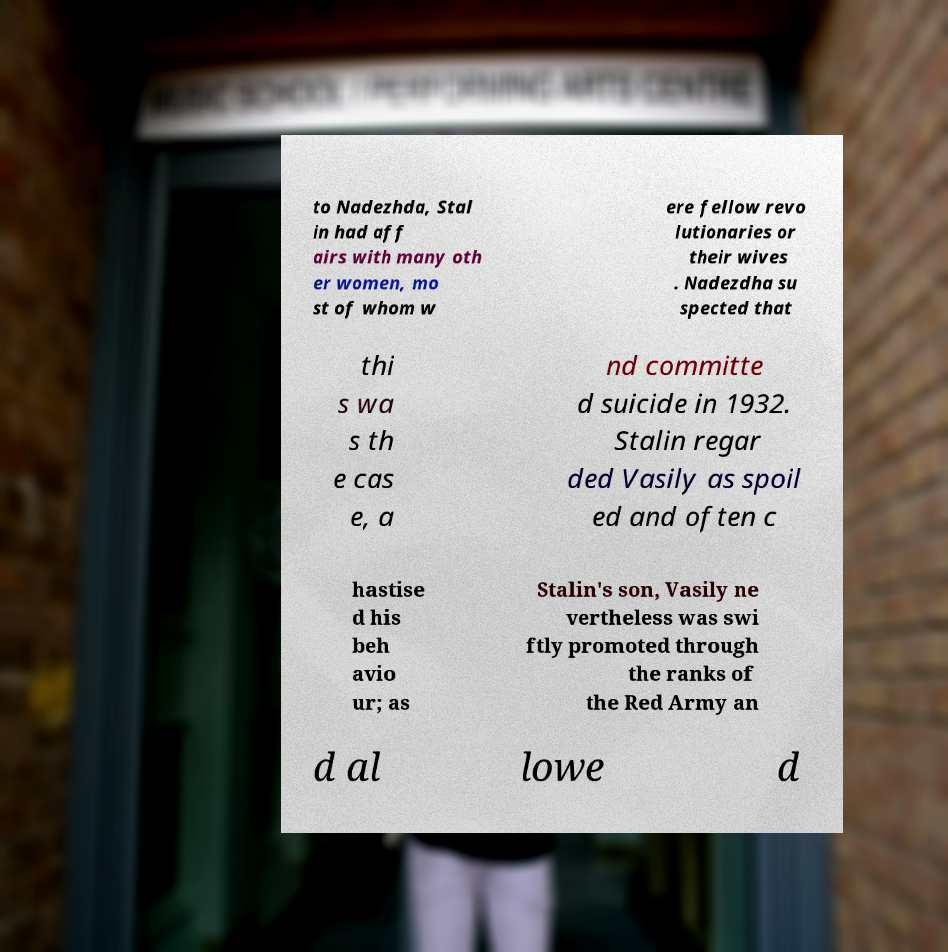Please identify and transcribe the text found in this image. to Nadezhda, Stal in had aff airs with many oth er women, mo st of whom w ere fellow revo lutionaries or their wives . Nadezdha su spected that thi s wa s th e cas e, a nd committe d suicide in 1932. Stalin regar ded Vasily as spoil ed and often c hastise d his beh avio ur; as Stalin's son, Vasily ne vertheless was swi ftly promoted through the ranks of the Red Army an d al lowe d 